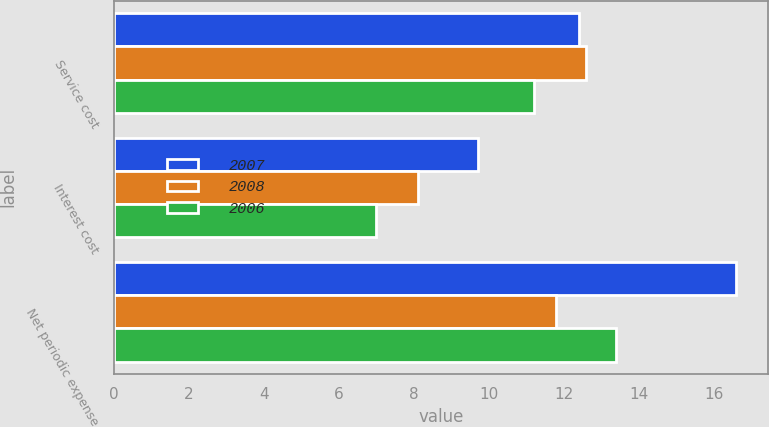<chart> <loc_0><loc_0><loc_500><loc_500><stacked_bar_chart><ecel><fcel>Service cost<fcel>Interest cost<fcel>Net periodic expense<nl><fcel>2007<fcel>12.4<fcel>9.7<fcel>16.6<nl><fcel>2008<fcel>12.6<fcel>8.1<fcel>11.8<nl><fcel>2006<fcel>11.2<fcel>7<fcel>13.4<nl></chart> 